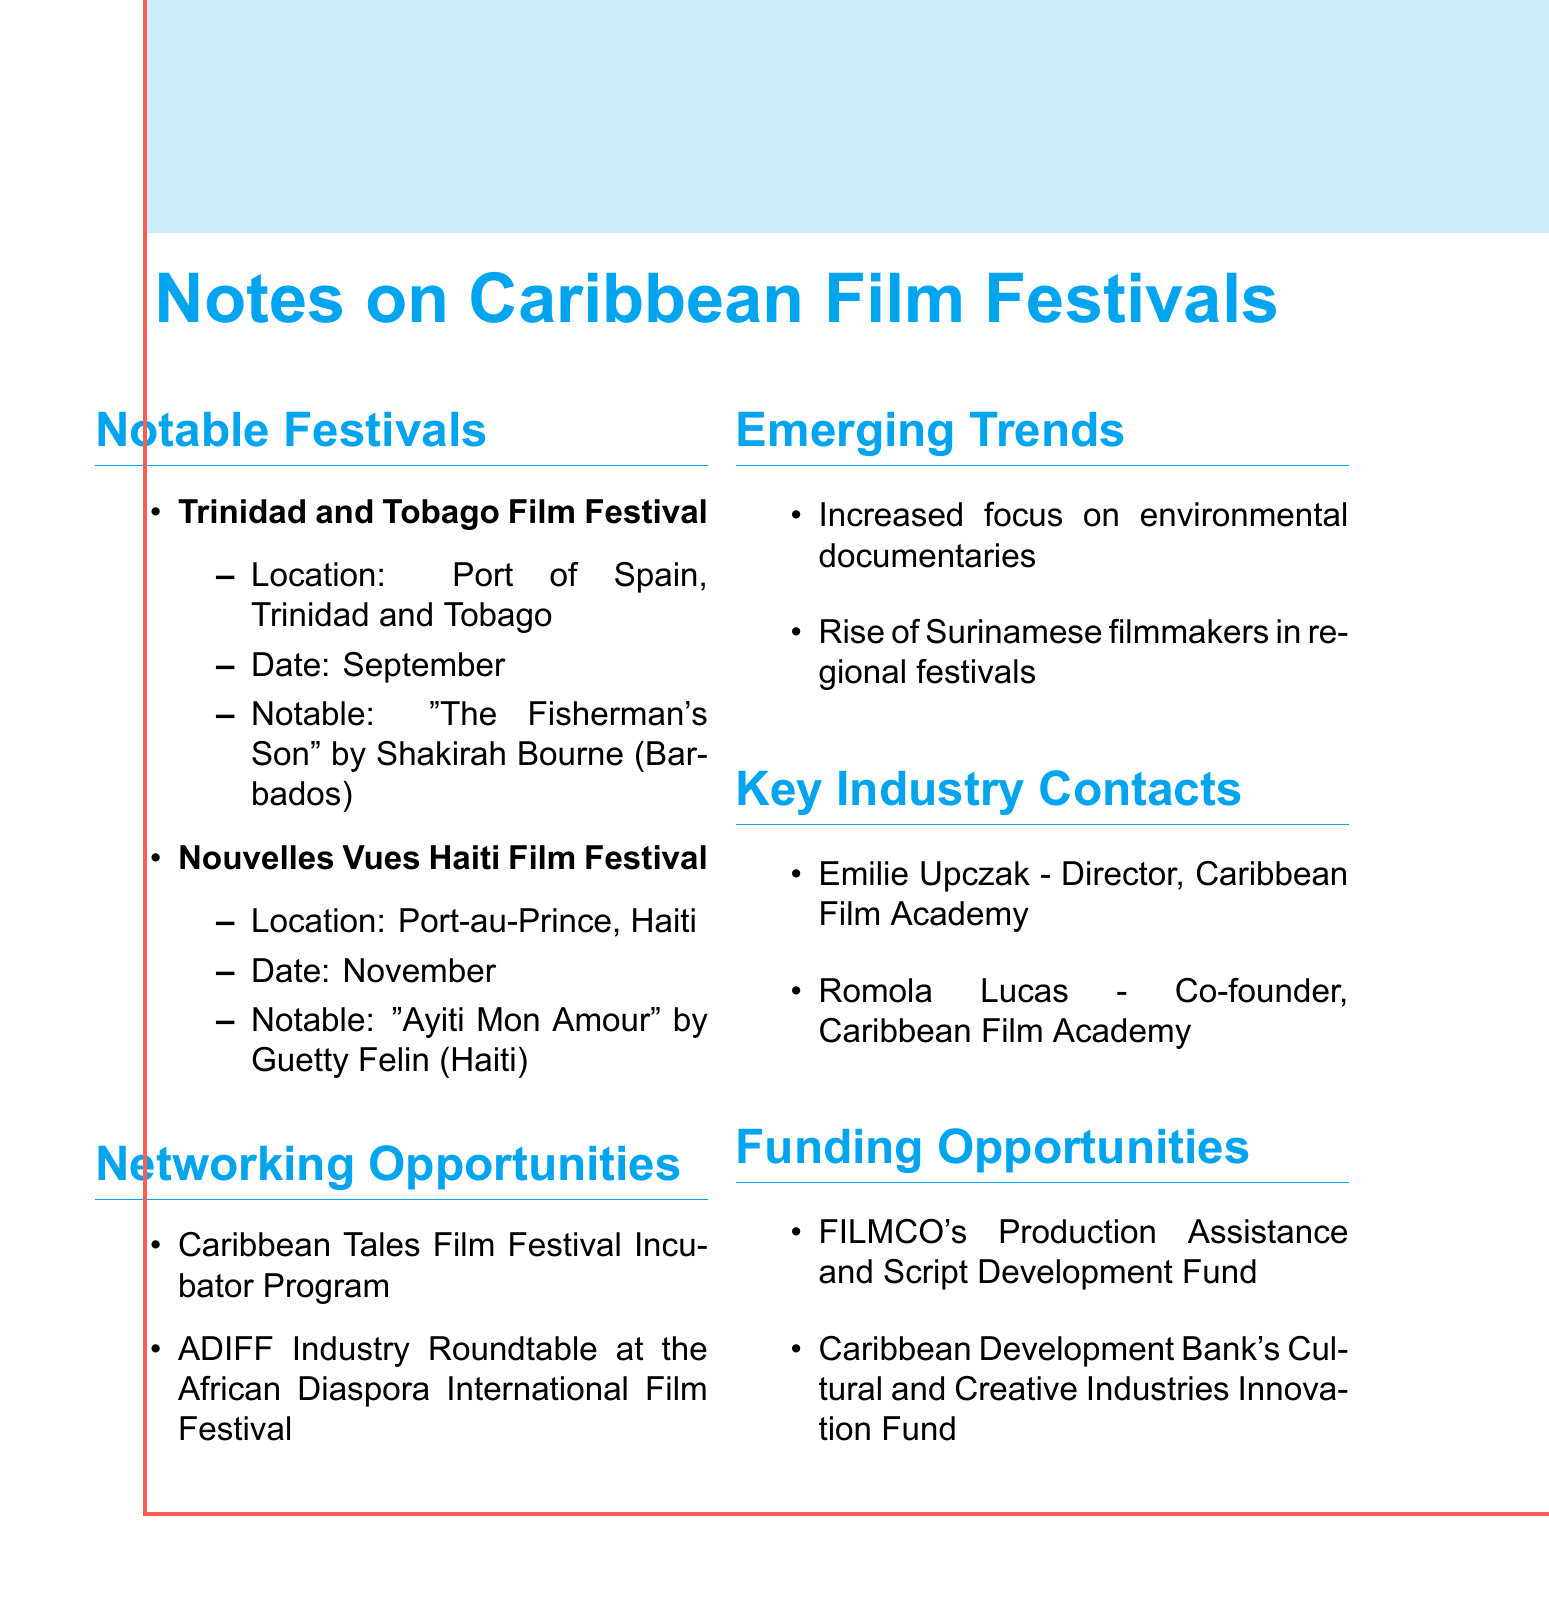What is the name of the film festival held in Trinidad and Tobago? The document lists the Trinidad and Tobago Film Festival as a notable festival, mentioning its location and date.
Answer: Trinidad and Tobago Film Festival In what month does the Nouvelles Vues Haiti Film Festival take place? The document specifies the date of the Nouvelles Vues Haiti Film Festival, indicating when it occurs.
Answer: November Who directed the notable submission "The Fisherman's Son"? The document identifies the notable submission from the Trinidad and Tobago Film Festival and the filmmaker's name associated with it.
Answer: Shakirah Bourne What is the focus of the emerging trend in Caribbean films? The document highlights two emerging trends in Caribbean films, specifically mentioning the rising focus on environmental themes.
Answer: Environmental documentaries Which organization offers a funding opportunity related to script development? The document lists specific funding opportunities, one of which pertains to script development.
Answer: FILMCO's Production Assistance and Script Development Fund What role does Emilie Upczak hold? The document provides information about key industry contacts, detailing their roles within the Caribbean Film Academy.
Answer: Director Name one networking opportunity mentioned in the document. The document lists two networking opportunities, highlighting programs related to film festivals.
Answer: Caribbean Tales Film Festival Incubator Program Which country is the filmmaker of "Ayiti Mon Amour" from? The document specifies the notable submission from the Nouvelles Vues Haiti Film Festival, including the filmmaker's country.
Answer: Haiti Who is the co-founder of the Caribbean Film Academy? The document identifies key industry contacts and lists their roles, including the co-founder of the organization.
Answer: Romola Lucas 